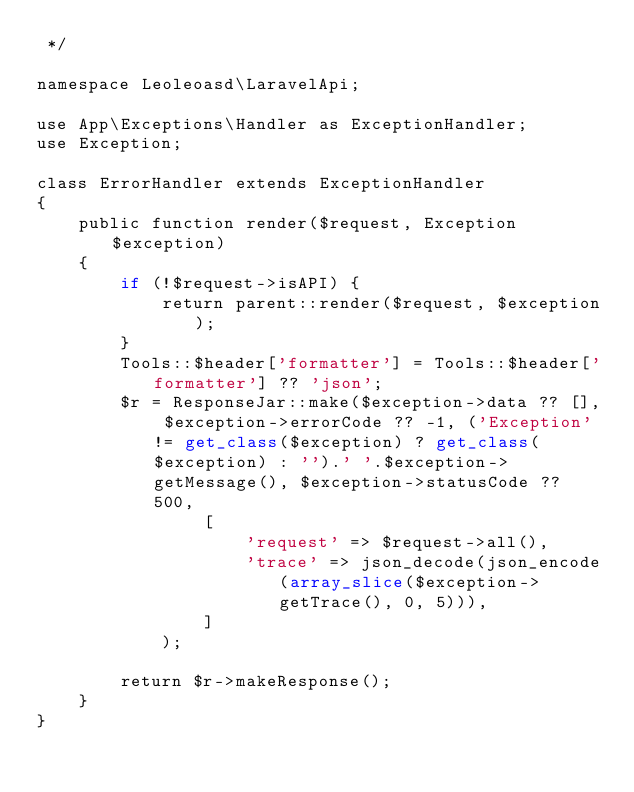<code> <loc_0><loc_0><loc_500><loc_500><_PHP_> */

namespace Leoleoasd\LaravelApi;

use App\Exceptions\Handler as ExceptionHandler;
use Exception;

class ErrorHandler extends ExceptionHandler
{
    public function render($request, Exception $exception)
    {
        if (!$request->isAPI) {
            return parent::render($request, $exception);
        }
        Tools::$header['formatter'] = Tools::$header['formatter'] ?? 'json';
        $r = ResponseJar::make($exception->data ?? [], $exception->errorCode ?? -1, ('Exception' != get_class($exception) ? get_class($exception) : '').' '.$exception->getMessage(), $exception->statusCode ?? 500,
                [
                    'request' => $request->all(),
                    'trace' => json_decode(json_encode(array_slice($exception->getTrace(), 0, 5))),
                ]
            );

        return $r->makeResponse();
    }
}
</code> 